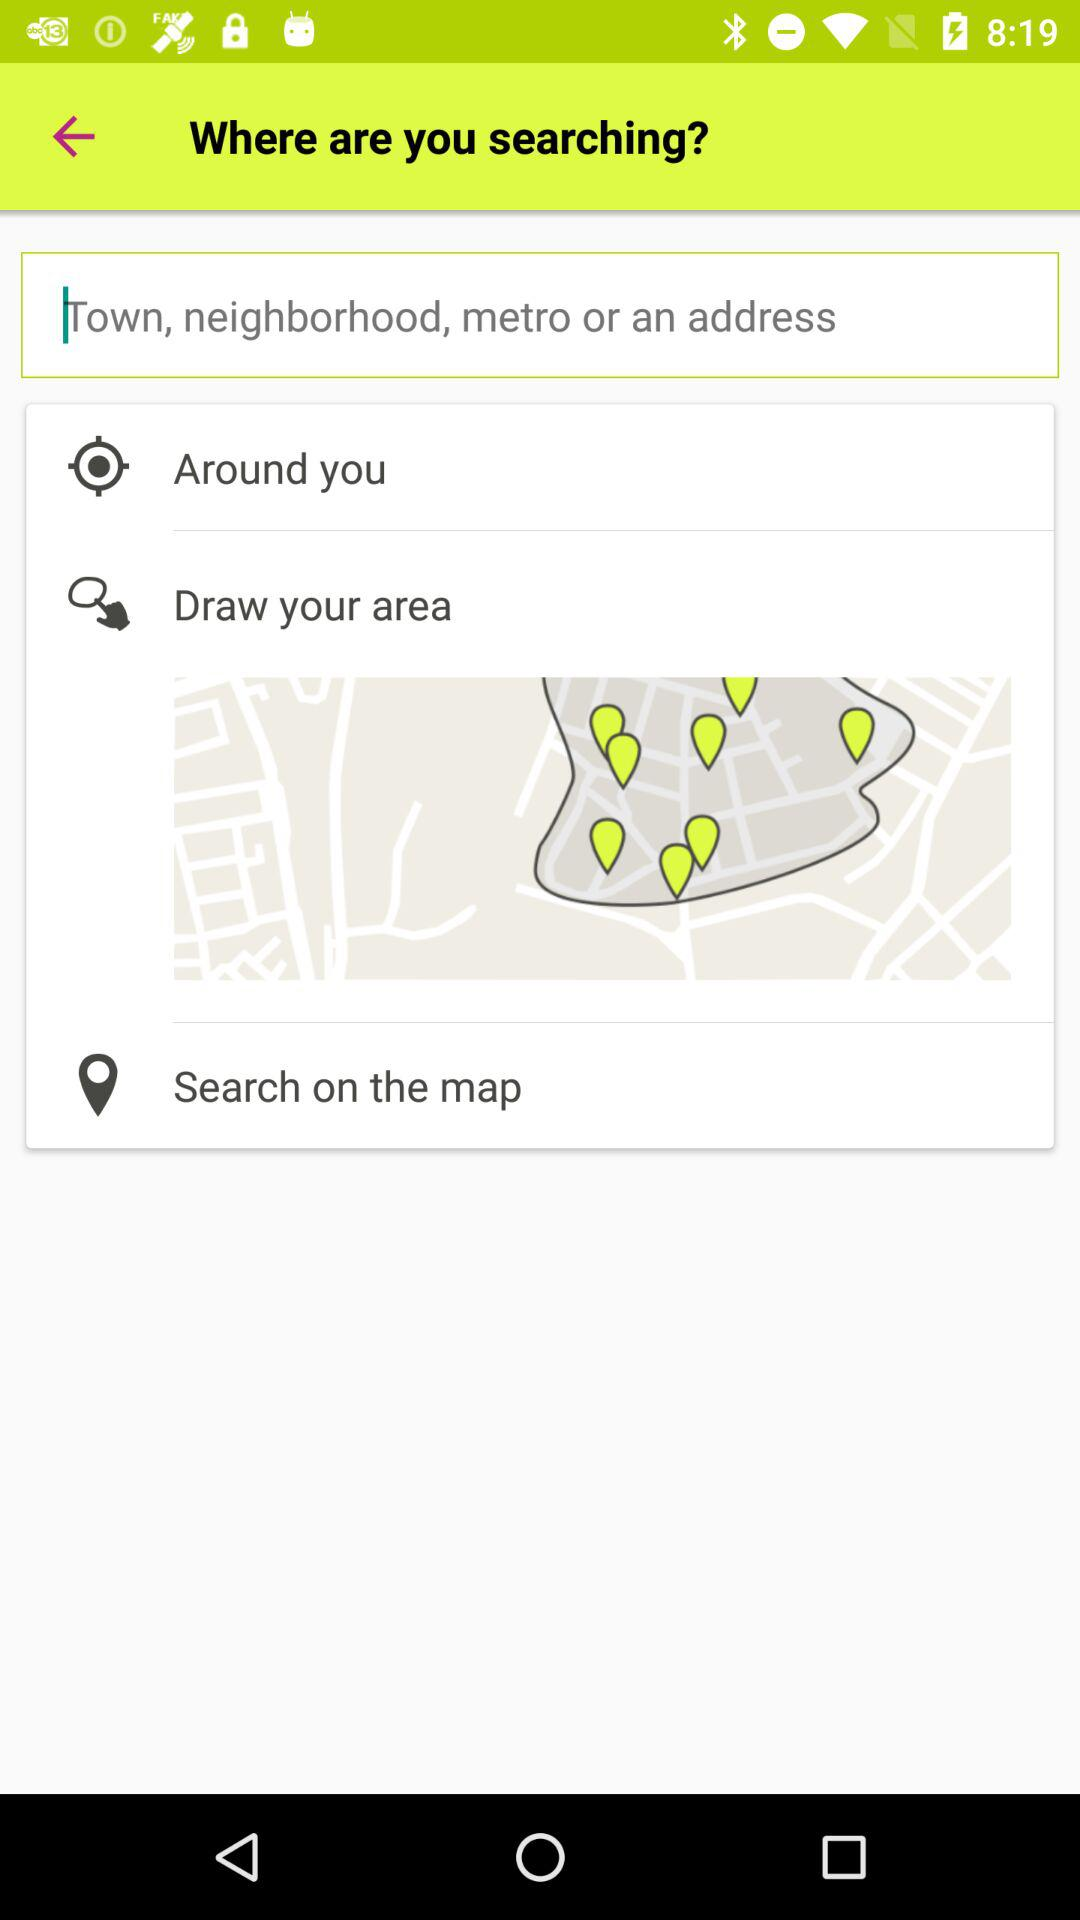Which city is entered in the search bar?
When the provided information is insufficient, respond with <no answer>. <no answer> 